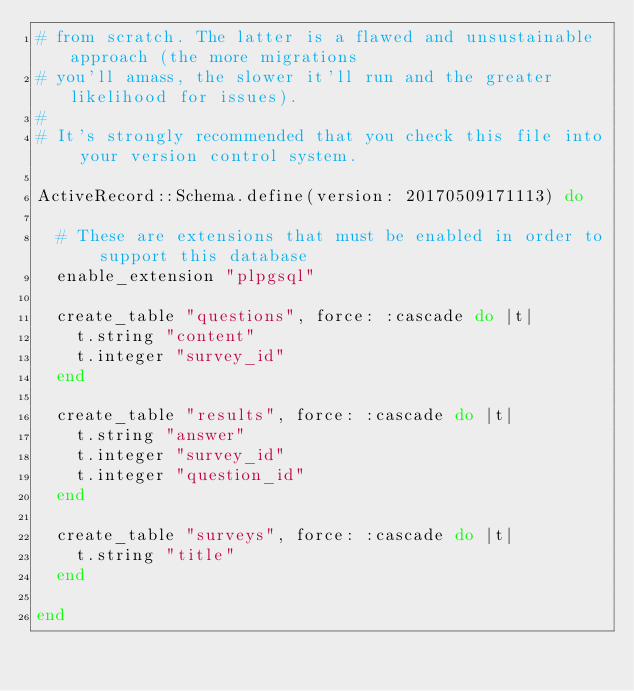<code> <loc_0><loc_0><loc_500><loc_500><_Ruby_># from scratch. The latter is a flawed and unsustainable approach (the more migrations
# you'll amass, the slower it'll run and the greater likelihood for issues).
#
# It's strongly recommended that you check this file into your version control system.

ActiveRecord::Schema.define(version: 20170509171113) do

  # These are extensions that must be enabled in order to support this database
  enable_extension "plpgsql"

  create_table "questions", force: :cascade do |t|
    t.string "content"
    t.integer "survey_id"
  end

  create_table "results", force: :cascade do |t|
    t.string "answer"
    t.integer "survey_id"
    t.integer "question_id"
  end

  create_table "surveys", force: :cascade do |t|
    t.string "title"
  end

end
</code> 